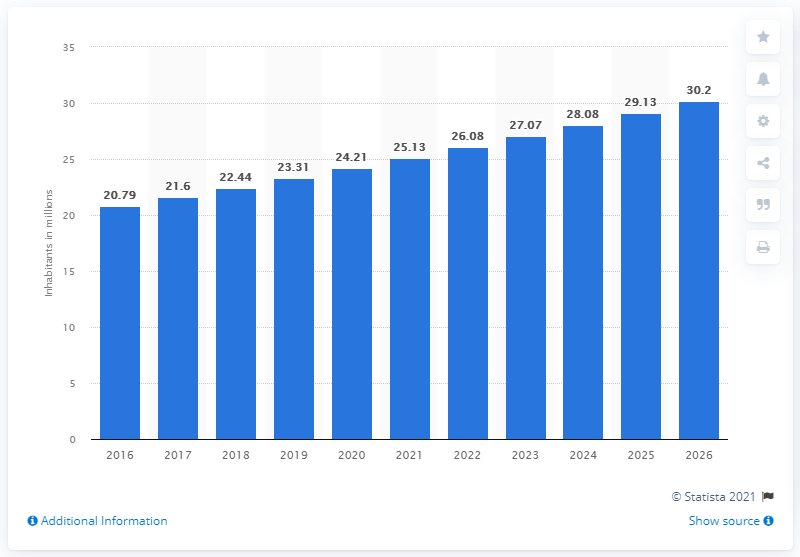Indicate a few pertinent items in this graphic. In 2020, the population of Niger was estimated to be 24.21 million. 